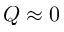Convert formula to latex. <formula><loc_0><loc_0><loc_500><loc_500>Q \approx 0</formula> 